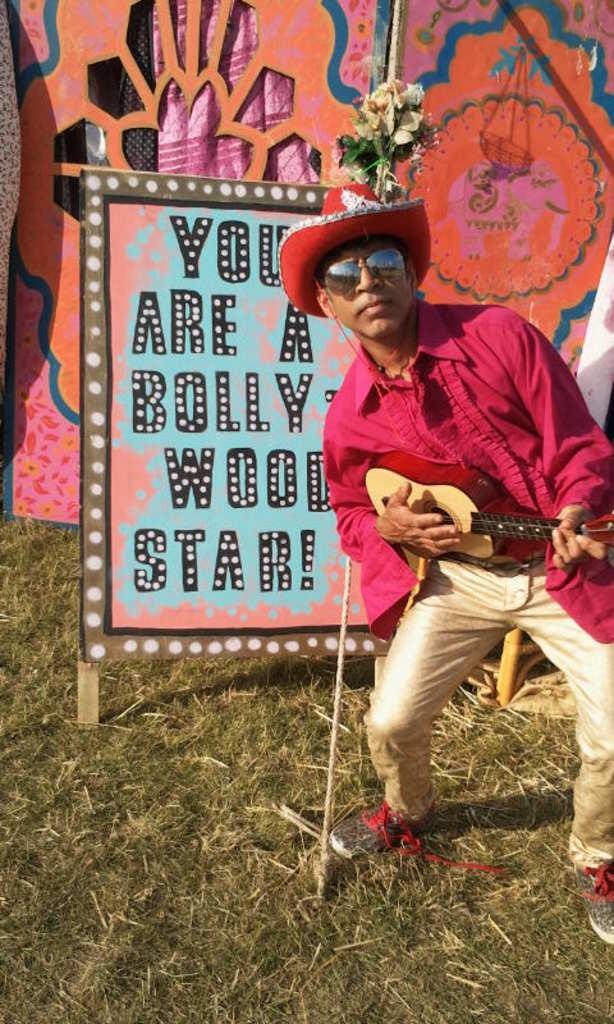Can you describe this image briefly? It is an open are there is a man who is wearing red color shirt and goggles he is playing guitar, behind this person there is a board there is something return like "you are a Bollywood star "on that ,behind the board there are some flowers and few other decorations. 